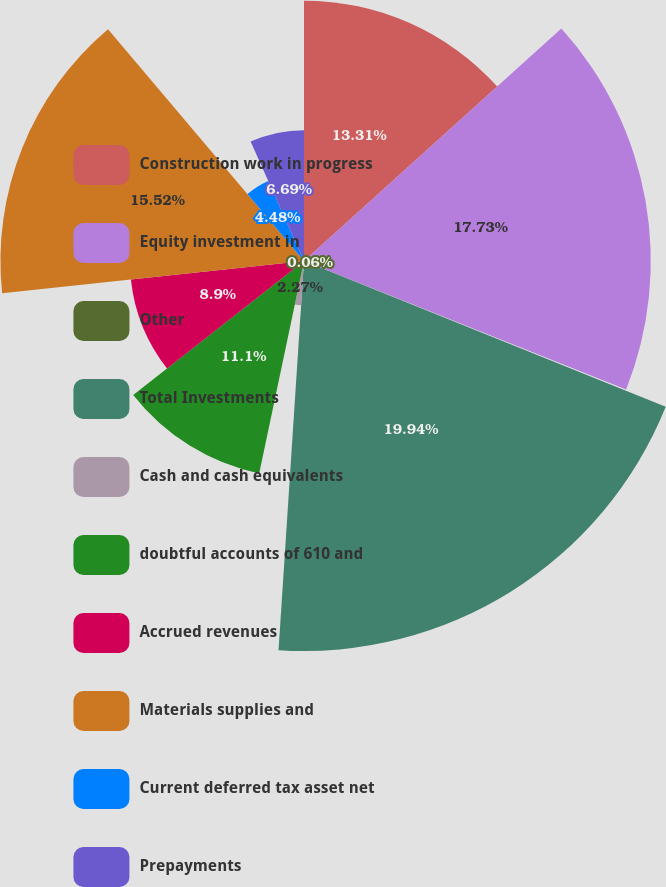Convert chart. <chart><loc_0><loc_0><loc_500><loc_500><pie_chart><fcel>Construction work in progress<fcel>Equity investment in<fcel>Other<fcel>Total Investments<fcel>Cash and cash equivalents<fcel>doubtful accounts of 610 and<fcel>Accrued revenues<fcel>Materials supplies and<fcel>Current deferred tax asset net<fcel>Prepayments<nl><fcel>13.31%<fcel>17.73%<fcel>0.06%<fcel>19.94%<fcel>2.27%<fcel>11.1%<fcel>8.9%<fcel>15.52%<fcel>4.48%<fcel>6.69%<nl></chart> 